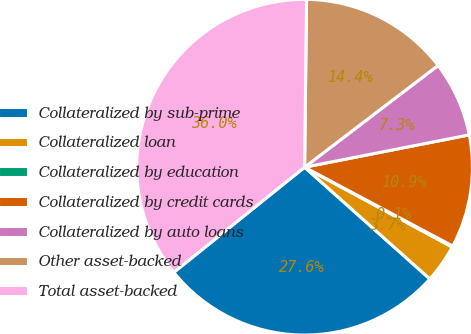Convert chart to OTSL. <chart><loc_0><loc_0><loc_500><loc_500><pie_chart><fcel>Collateralized by sub-prime<fcel>Collateralized loan<fcel>Collateralized by education<fcel>Collateralized by credit cards<fcel>Collateralized by auto loans<fcel>Other asset-backed<fcel>Total asset-backed<nl><fcel>27.63%<fcel>3.7%<fcel>0.11%<fcel>10.87%<fcel>7.28%<fcel>14.45%<fcel>35.96%<nl></chart> 